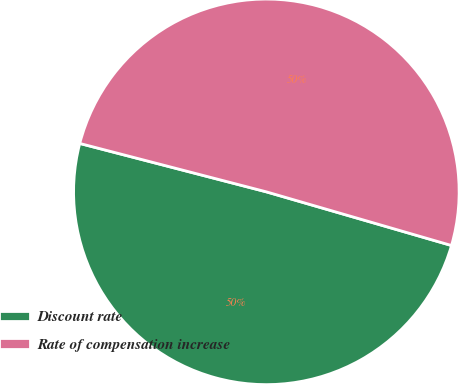<chart> <loc_0><loc_0><loc_500><loc_500><pie_chart><fcel>Discount rate<fcel>Rate of compensation increase<nl><fcel>49.55%<fcel>50.45%<nl></chart> 